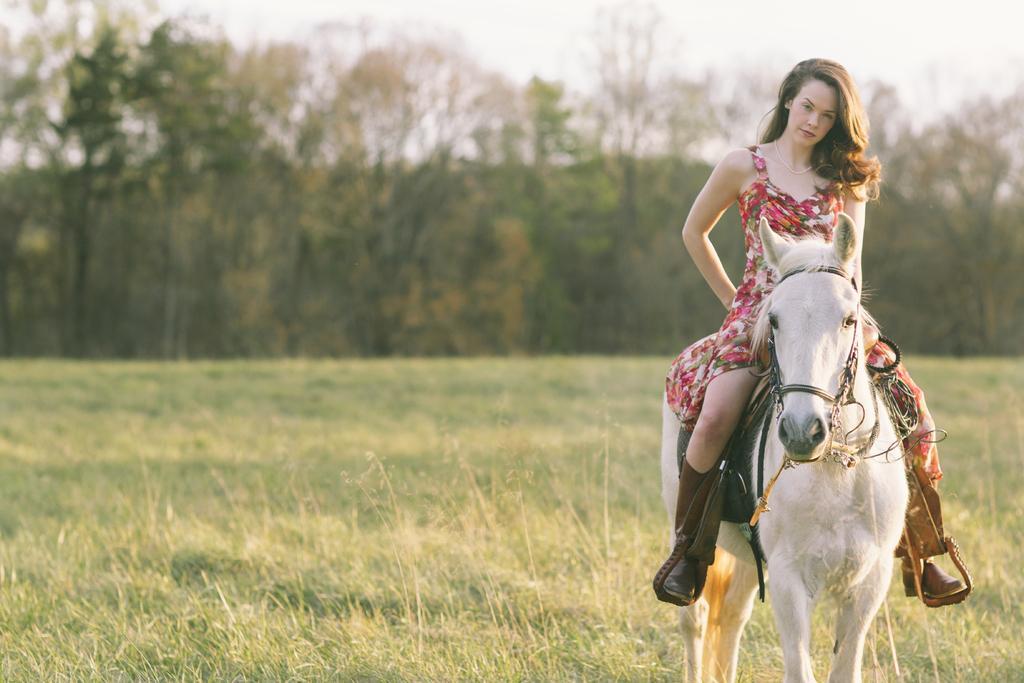Please provide a concise description of this image. In this image we can see a lady sitting on the white horse. In the background we can see many trees. 